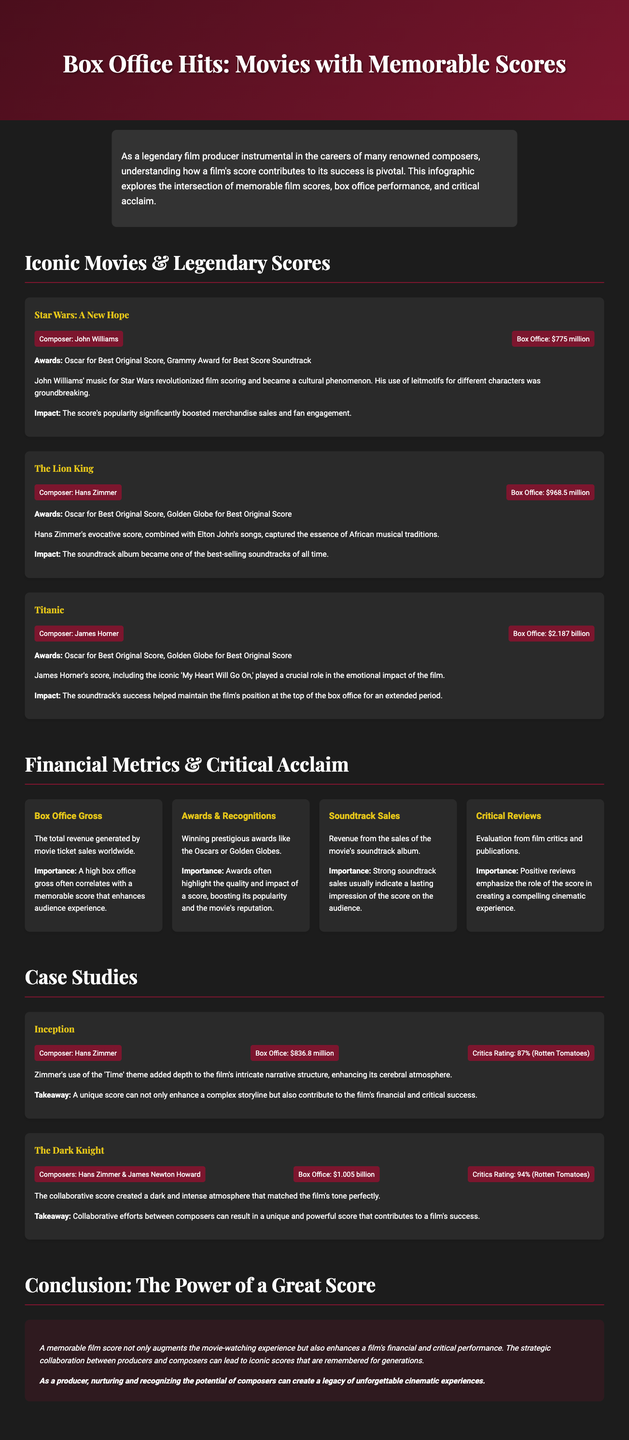what is the composer of Star Wars: A New Hope? The composer of Star Wars: A New Hope is John Williams.
Answer: John Williams what was the box office gross of Titanic? The box office gross of Titanic is mentioned as $2.187 billion.
Answer: $2.187 billion which movie had a box office gross of $968.5 million? The Lion King had a box office gross of $968.5 million.
Answer: The Lion King what award did The Lion King win? The Lion King won the Oscar for Best Original Score.
Answer: Oscar for Best Original Score how much revenue did the movie Inception generate? Inception generated a box office gross of $836.8 million.
Answer: $836.8 million which composer's score was used in The Dark Knight? The Dark Knight used the score by Hans Zimmer & James Newton Howard.
Answer: Hans Zimmer & James Newton Howard what is the critical rating of Inception on Rotten Tomatoes? Inception has a critics rating of 87% on Rotten Tomatoes.
Answer: 87% what is the common theme across the case studies? Both case studies focus on significant contributions of composers to the movies mentioned.
Answer: Significant contributions what metric correlates with the quality and impact of a score? Winning prestigious awards such as the Oscars or Golden Globes correlates with the quality and impact of a score.
Answer: Winning prestigious awards 